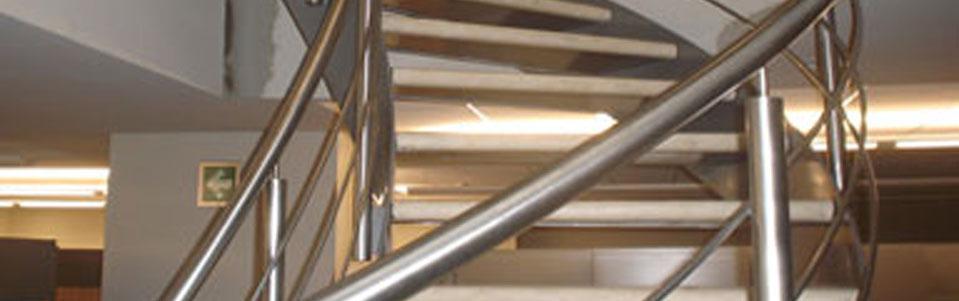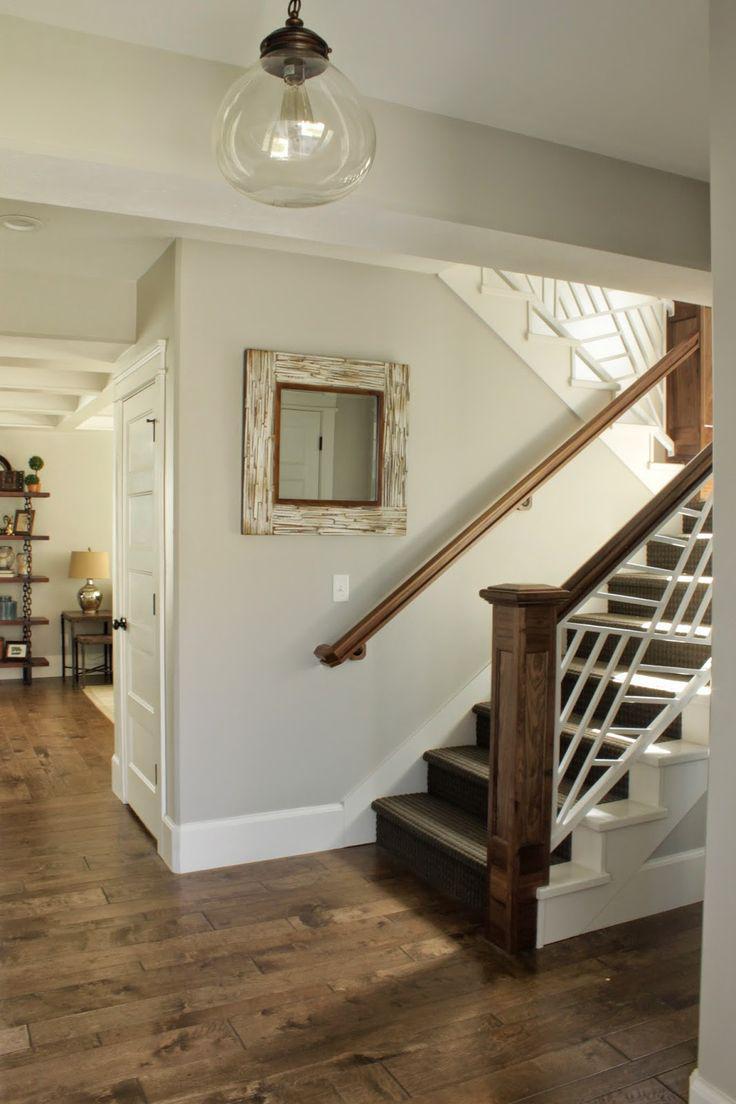The first image is the image on the left, the second image is the image on the right. Analyze the images presented: Is the assertion "The staircase in the image on the right comes down near a striped wall." valid? Answer yes or no. No. 